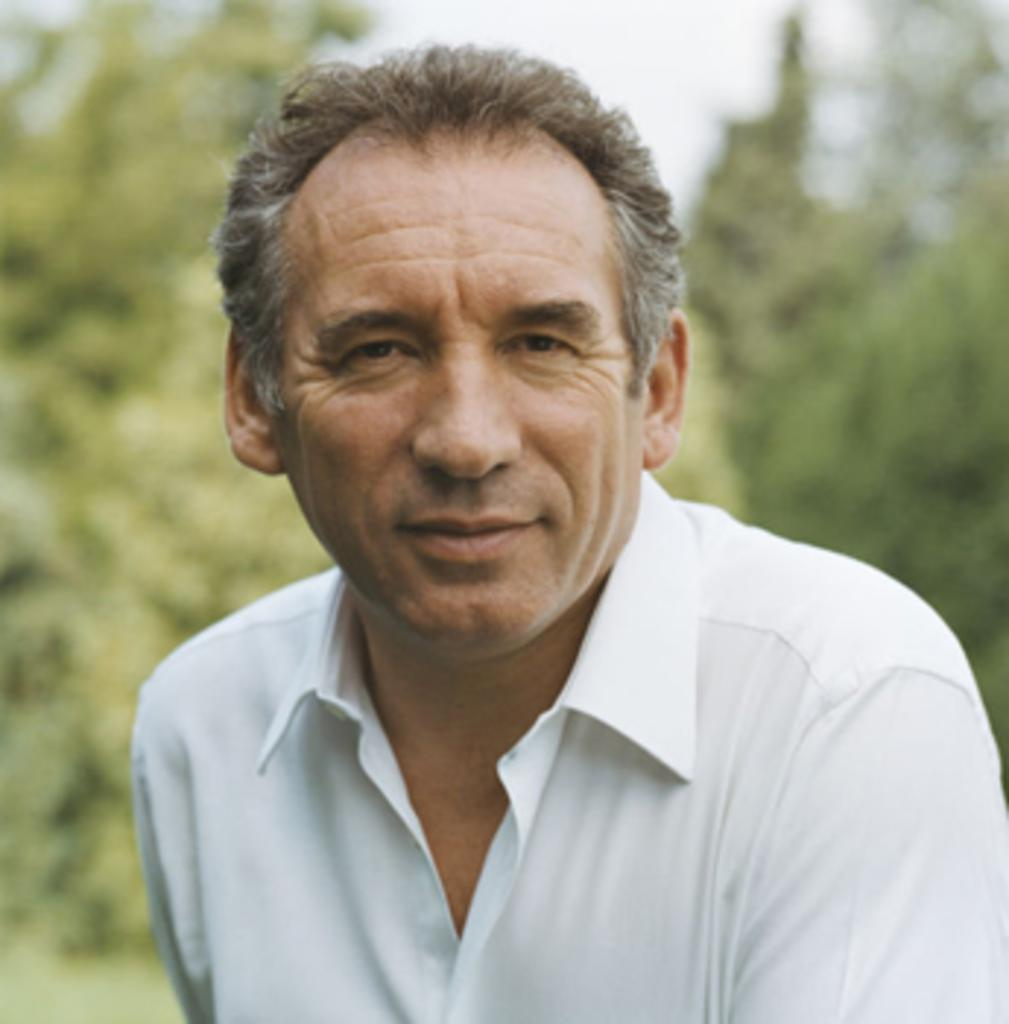What is present in the image? There is a person in the image. What is the person wearing? The person is wearing a white shirt. What can be seen in the background of the image? There are trees visible behind the person. How many lizards are involved in the fight in the image? There are no lizards or fights present in the image. What type of oven is visible in the image? There is no oven present in the image. 